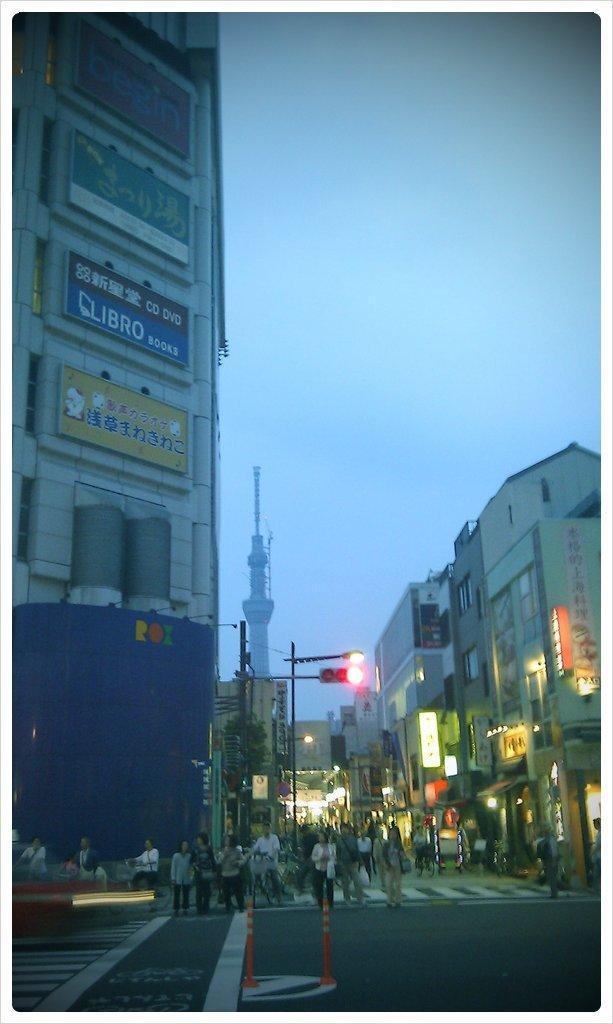In one or two sentences, can you explain what this image depicts? In this picture we can see few buildings and group of people, in the background we can find few poles, traffic lights, hoardings and lights. 